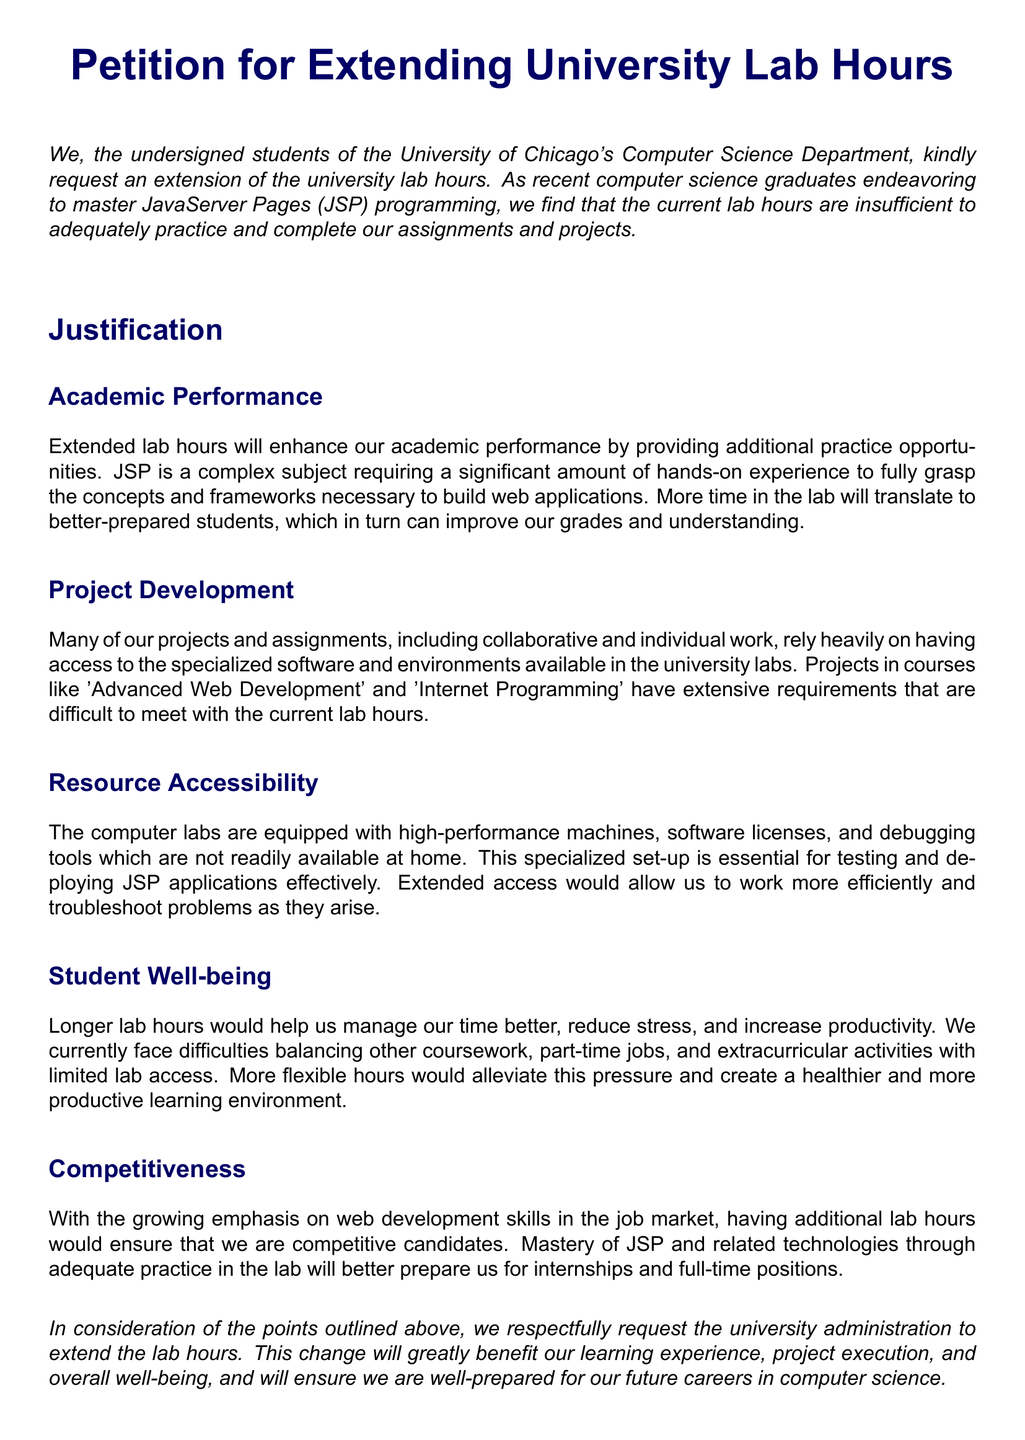What is the title of the petition? The title of the petition is mentioned at the beginning of the document.
Answer: Petition for Extending University Lab Hours Who are the signatories of the petition? The petition is signed by students from a specific department at the university.
Answer: students of the University of Chicago's Computer Science Department What is the main request of the petition? The main request is conveyed in the opening paragraph of the document.
Answer: Extension of the university lab hours What subject do the students find complex? The subject in focus, which the students find challenging, is clearly stated.
Answer: JavaServer Pages (JSP) How does the petition suggest extended lab hours would impact academic performance? The impact on academic performance is discussed in a specific section of the petition.
Answer: Enhance academic performance What type of projects rely on university lab access? The type of projects needing lab access are indicated in the document.
Answer: Advanced Web Development and Internet Programming What equipment do the computer labs provide? The document mentions specific resources available in the labs that are not at home.
Answer: High-performance machines, software licenses, and debugging tools What is one benefit of longer lab hours mentioned in relation to student well-being? A specific benefit in connection to student well-being is highlighted in the petition.
Answer: Reduce stress What aspect of future careers is emphasized in the petition's final reasoning? The petition states an important aspect related to future career preparation.
Answer: Competitiveness in the job market 